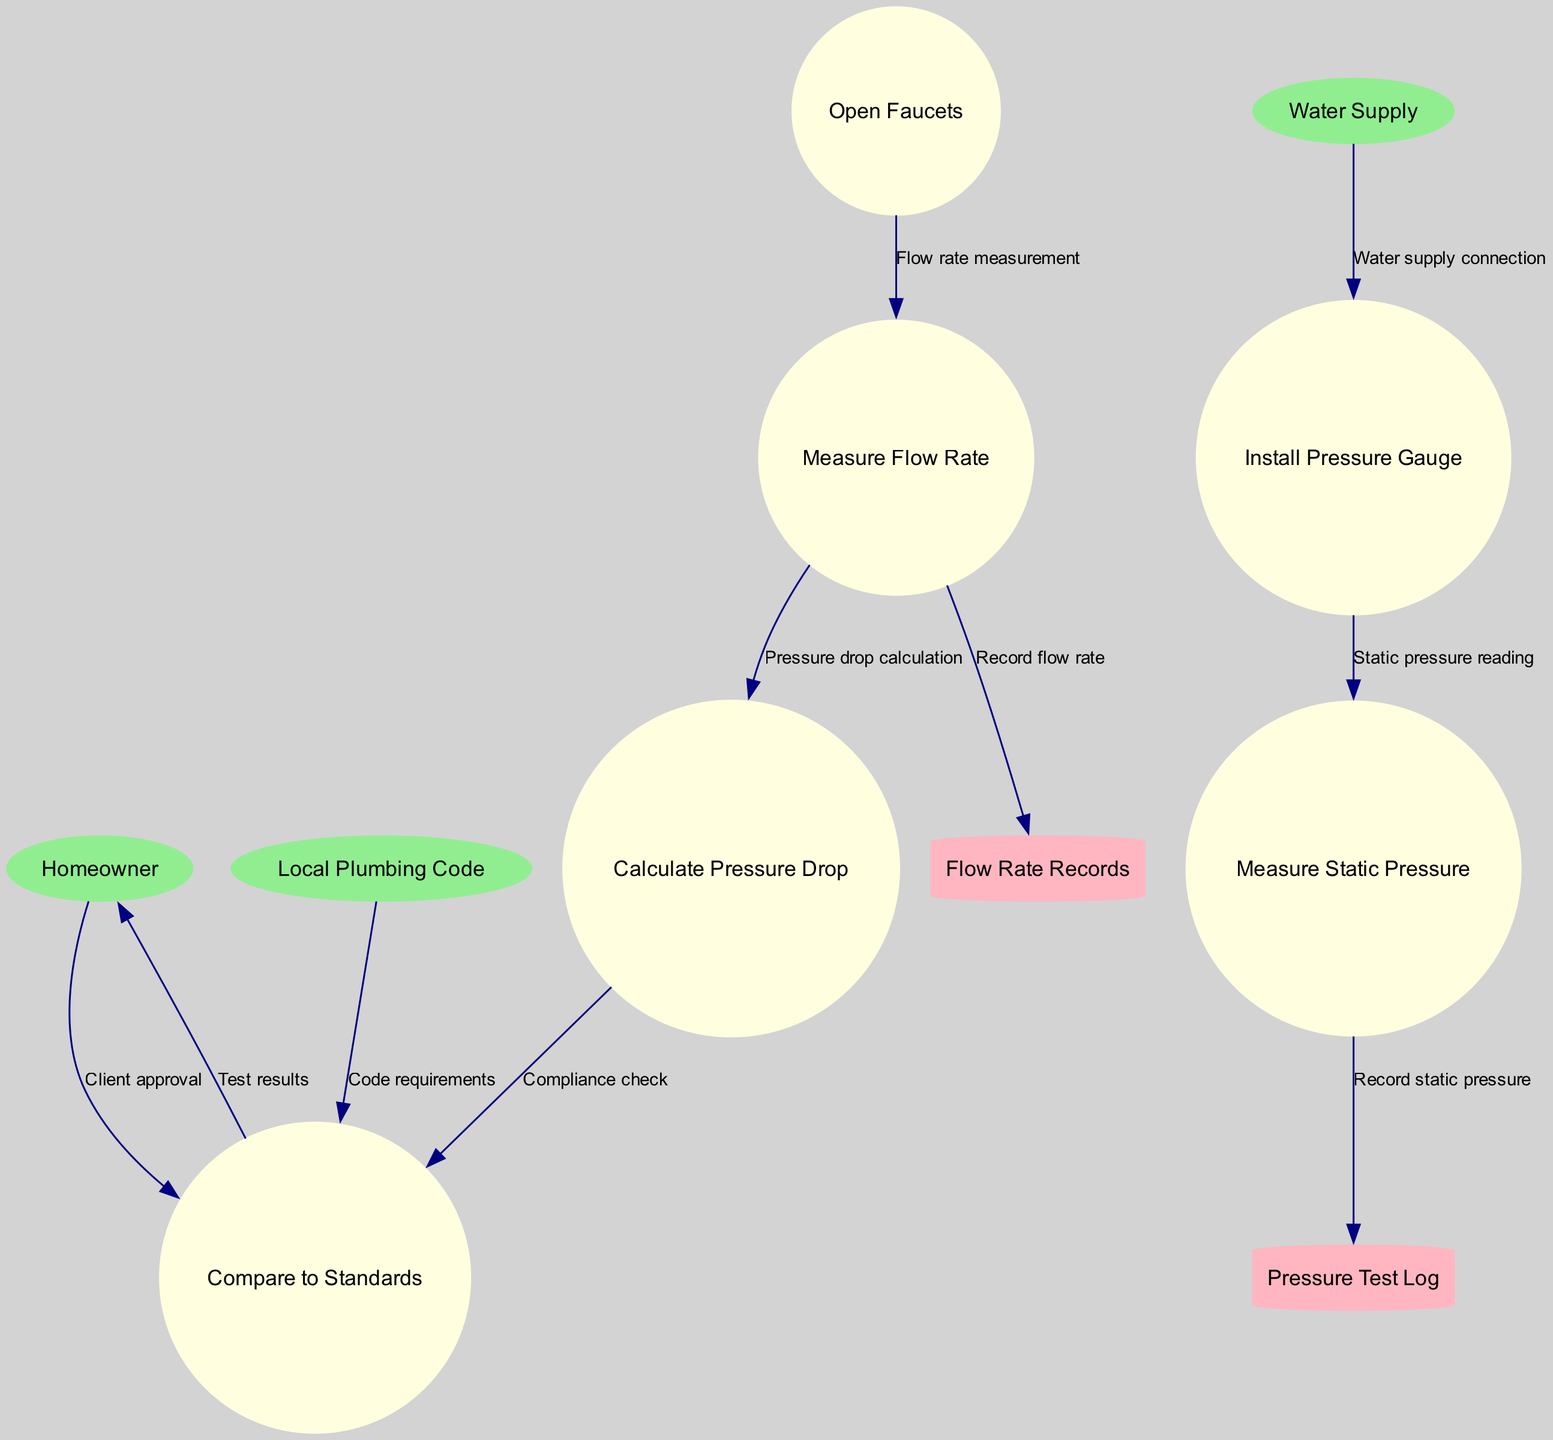What are the external entities in the diagram? The external entities identified in the diagram are listed clearly as "Homeowner", "Water Supply", and "Local Plumbing Code".
Answer: Homeowner, Water Supply, Local Plumbing Code How many processes are there in the diagram? The diagram contains six distinct processes: "Install Pressure Gauge", "Measure Static Pressure", "Open Faucets", "Measure Flow Rate", "Calculate Pressure Drop", and "Compare to Standards".
Answer: 6 Which process follows "Measure Flow Rate"? The diagram shows that "Calculate Pressure Drop" directly follows "Measure Flow Rate", as indicated by the connecting edge.
Answer: Calculate Pressure Drop What type of data store is "Pressure Test Log"? In the diagram, "Pressure Test Log" is represented as a cylinder, which indicates that it is a data store in this context.
Answer: Data store What is the flow that connects "Install Pressure Gauge" to "Measure Static Pressure"? The flow labeled as "Static pressure reading" connects these two processes in the diagram.
Answer: Static pressure reading What occurs after "Compare to Standards"? Following "Compare to Standards", the process sends "Test results" to the "Homeowner", as outlined by the connecting flow in the diagram.
Answer: Test results How does the "Local Plumbing Code" relate to "Compare to Standards"? The "Local Plumbing Code" sends "Code requirements" to "Compare to Standards", establishing its role in the compliance measurement depicted in the flow.
Answer: Code requirements What does the "Measure Flow Rate" process record? According to the diagram, the "Measure Flow Rate" process records information in the "Flow Rate Records" data store, indicating that it tracks flow measurements.
Answer: Record flow rate 